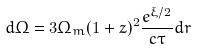<formula> <loc_0><loc_0><loc_500><loc_500>d \Omega = 3 \Omega _ { m } ( 1 + z ) ^ { 2 } \frac { e ^ { \xi / 2 } } { c \tau } d r</formula> 